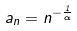Convert formula to latex. <formula><loc_0><loc_0><loc_500><loc_500>a _ { n } = n ^ { - \frac { 1 } { \alpha } }</formula> 